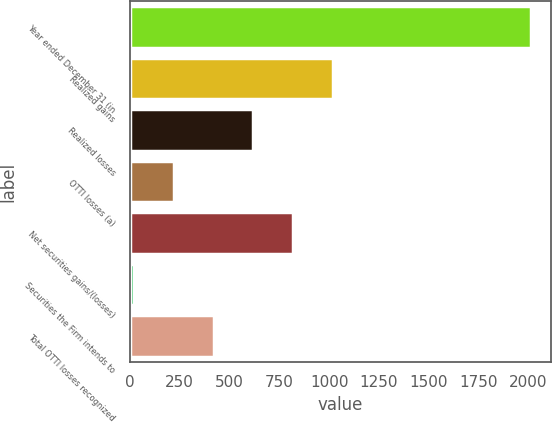Convert chart. <chart><loc_0><loc_0><loc_500><loc_500><bar_chart><fcel>Year ended December 31 (in<fcel>Realized gains<fcel>Realized losses<fcel>OTTI losses (a)<fcel>Net securities gains/(losses)<fcel>Securities the Firm intends to<fcel>Total OTTI losses recognized<nl><fcel>2015<fcel>1018<fcel>619.2<fcel>220.4<fcel>818.6<fcel>21<fcel>419.8<nl></chart> 